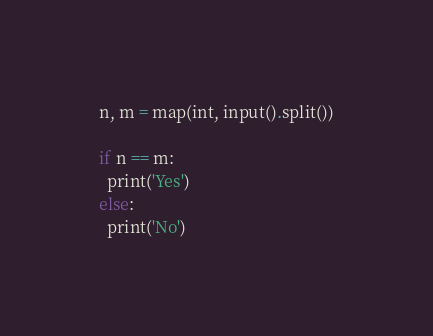Convert code to text. <code><loc_0><loc_0><loc_500><loc_500><_Python_>n, m = map(int, input().split())

if n == m:
  print('Yes')
else:
  print('No')</code> 